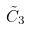Convert formula to latex. <formula><loc_0><loc_0><loc_500><loc_500>\tilde { C } _ { 3 }</formula> 